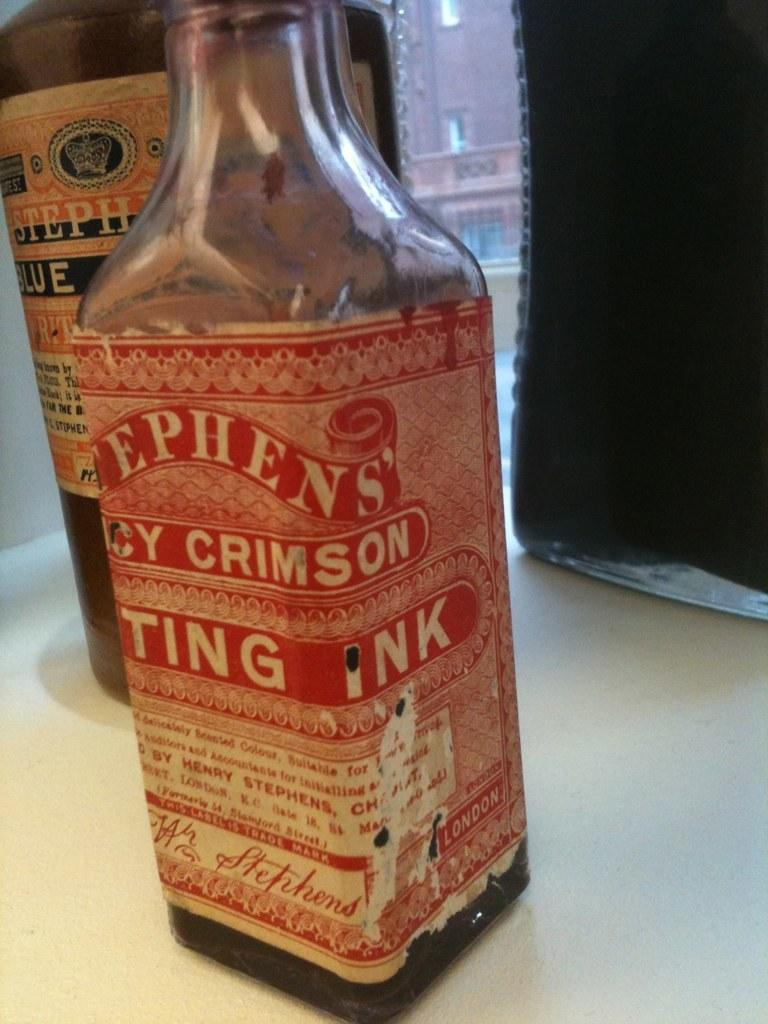Provide a one-sentence caption for the provided image. Bottles of Stephen's ink sit near a window, the label on the crimson bottle slightly worn. 